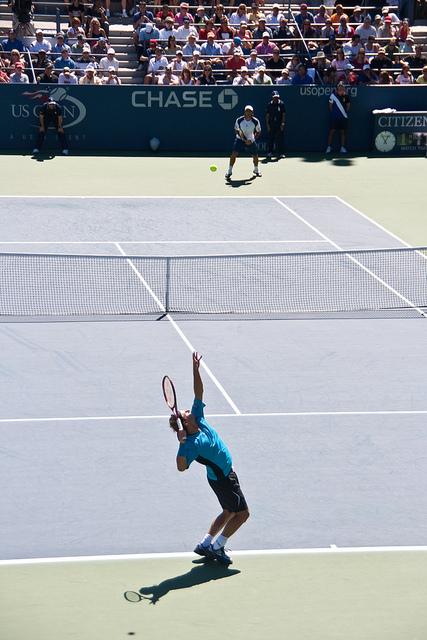Are there spectators?
Quick response, please. Yes. What sport is the man playing?
Keep it brief. Tennis. Which tennis player is serving?
Give a very brief answer. One in blue. 